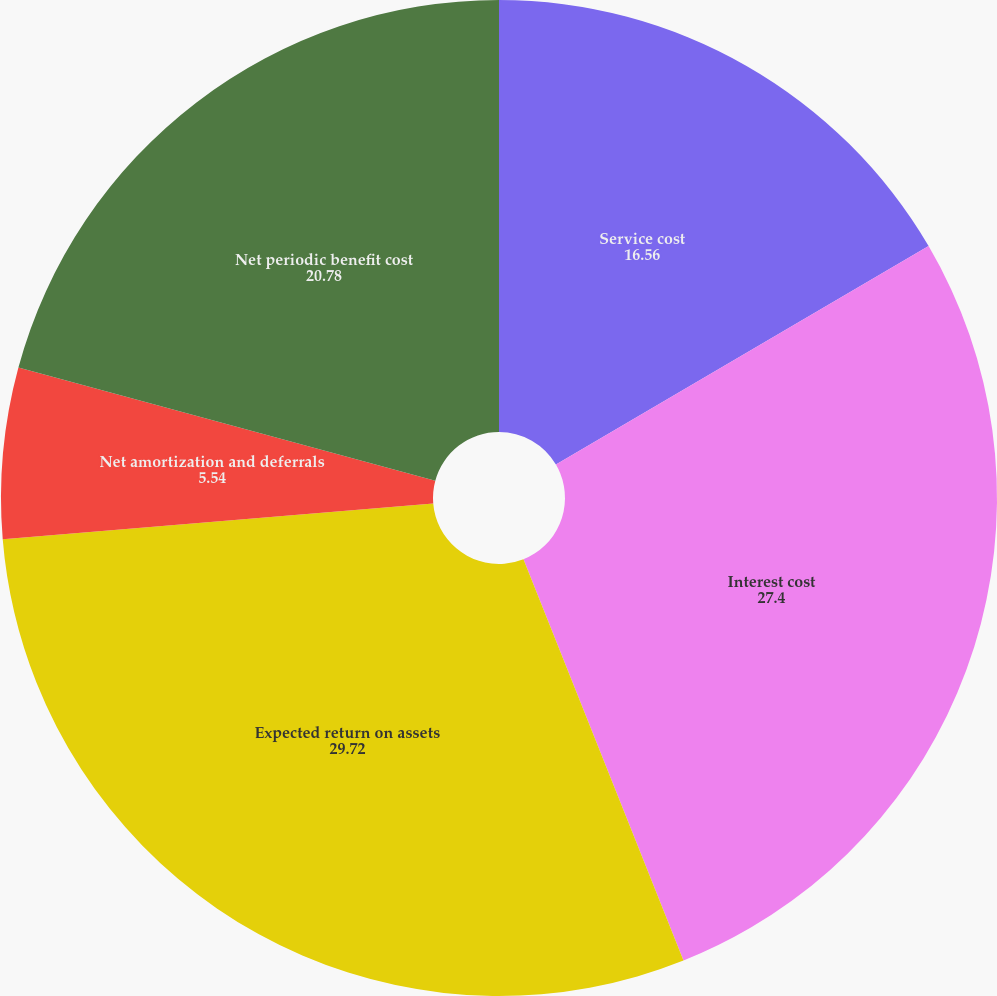Convert chart. <chart><loc_0><loc_0><loc_500><loc_500><pie_chart><fcel>Service cost<fcel>Interest cost<fcel>Expected return on assets<fcel>Net amortization and deferrals<fcel>Net periodic benefit cost<nl><fcel>16.56%<fcel>27.4%<fcel>29.72%<fcel>5.54%<fcel>20.78%<nl></chart> 